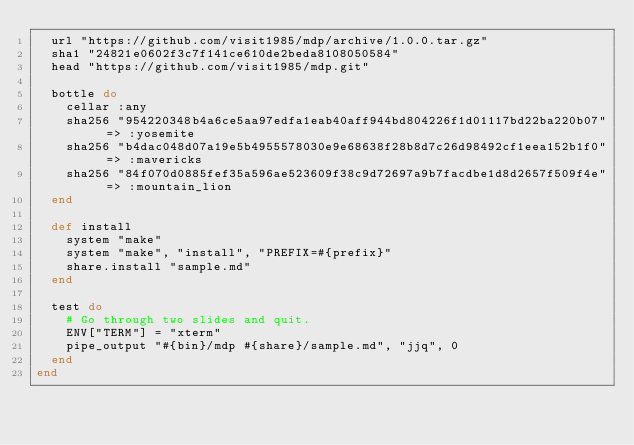Convert code to text. <code><loc_0><loc_0><loc_500><loc_500><_Ruby_>  url "https://github.com/visit1985/mdp/archive/1.0.0.tar.gz"
  sha1 "24821e0602f3c7f141ce610de2beda8108050584"
  head "https://github.com/visit1985/mdp.git"

  bottle do
    cellar :any
    sha256 "954220348b4a6ce5aa97edfa1eab40aff944bd804226f1d01117bd22ba220b07" => :yosemite
    sha256 "b4dac048d07a19e5b4955578030e9e68638f28b8d7c26d98492cf1eea152b1f0" => :mavericks
    sha256 "84f070d0885fef35a596ae523609f38c9d72697a9b7facdbe1d8d2657f509f4e" => :mountain_lion
  end

  def install
    system "make"
    system "make", "install", "PREFIX=#{prefix}"
    share.install "sample.md"
  end

  test do
    # Go through two slides and quit.
    ENV["TERM"] = "xterm"
    pipe_output "#{bin}/mdp #{share}/sample.md", "jjq", 0
  end
end
</code> 